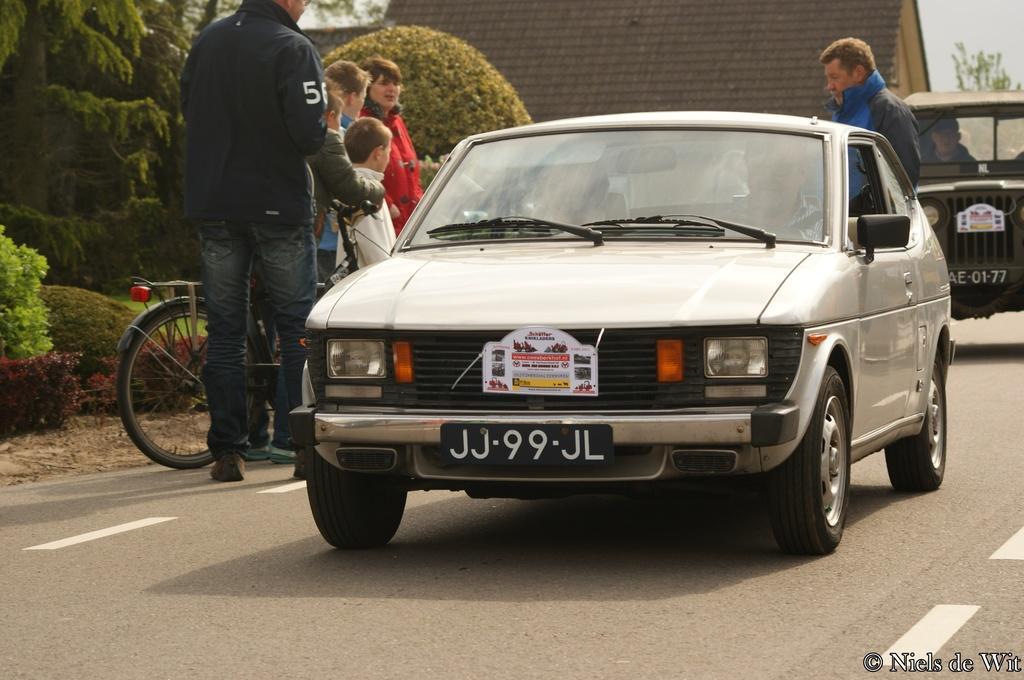How would you summarize this image in a sentence or two? In this image I can see there is a car on the road, on the left side there are people and there are trees. At the top it looks like a house, in the right hand side bottom there is the text. 